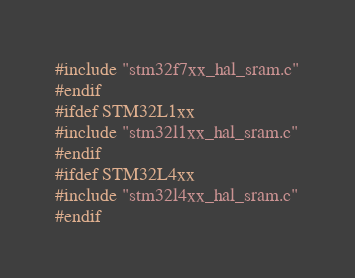Convert code to text. <code><loc_0><loc_0><loc_500><loc_500><_C_>#include "stm32f7xx_hal_sram.c"
#endif
#ifdef STM32L1xx
#include "stm32l1xx_hal_sram.c"
#endif
#ifdef STM32L4xx
#include "stm32l4xx_hal_sram.c"
#endif
</code> 